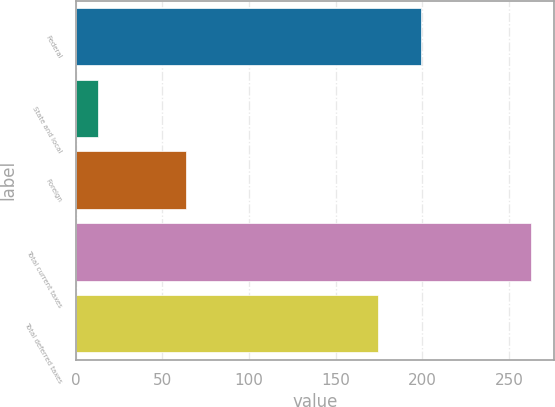Convert chart to OTSL. <chart><loc_0><loc_0><loc_500><loc_500><bar_chart><fcel>Federal<fcel>State and local<fcel>Foreign<fcel>Total current taxes<fcel>Total deferred taxes<nl><fcel>199.16<fcel>13.1<fcel>63.4<fcel>262.7<fcel>174.2<nl></chart> 